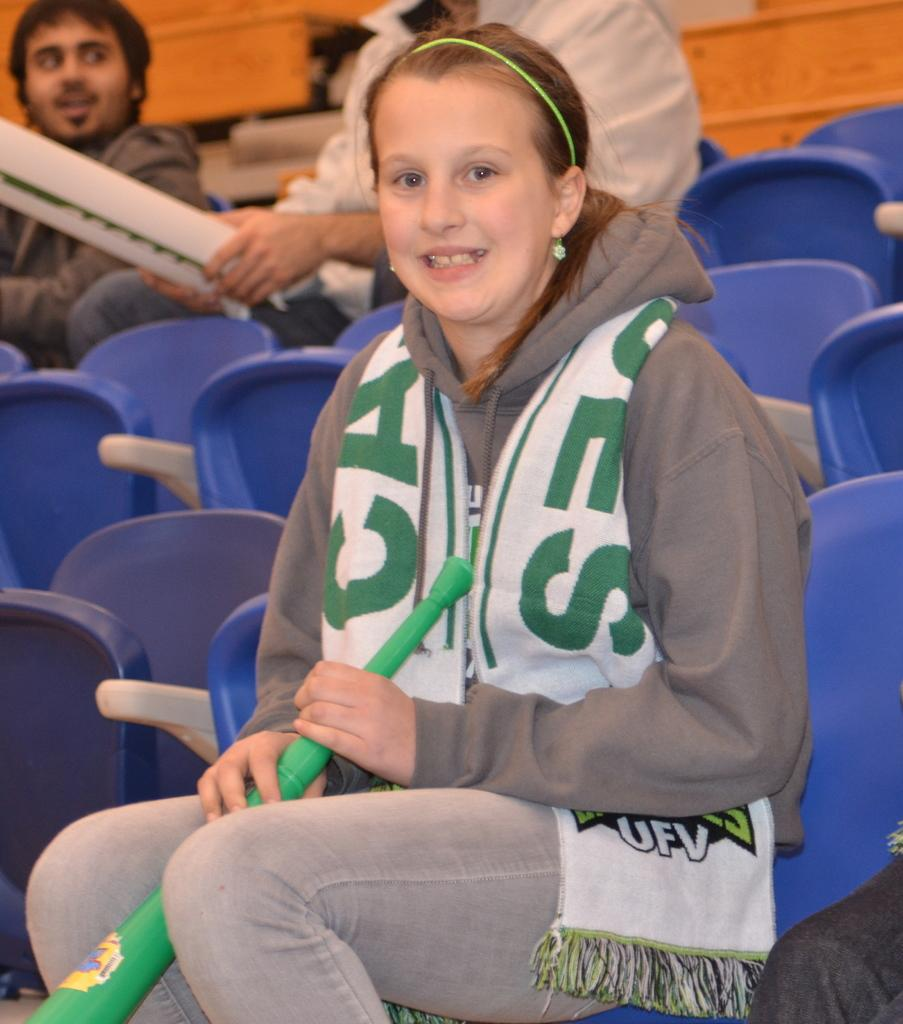<image>
Relay a brief, clear account of the picture shown. A woman wearing a white and green scarf with the letters UFV towards the bottom. 